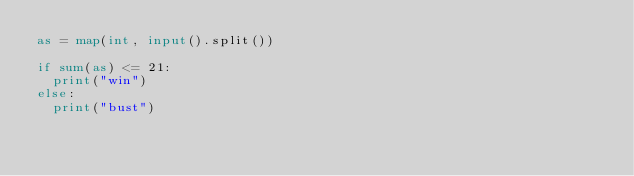<code> <loc_0><loc_0><loc_500><loc_500><_Python_>as = map(int, input().split())
 
if sum(as) <= 21:
  print("win")
else:
  print("bust")</code> 